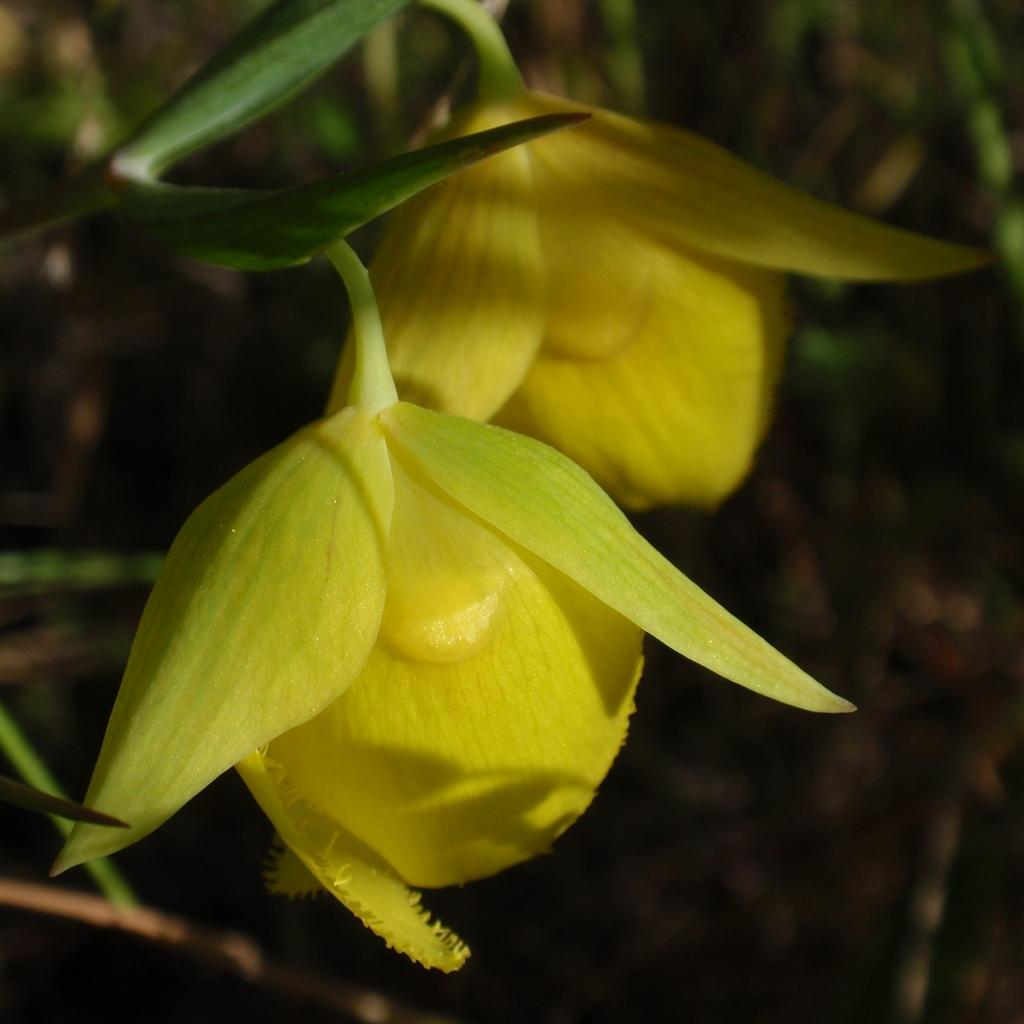What type of flowers can be seen in the image? There are yellow flowers in the image. Can you describe the background of the image? The background of the image is blurred. What type of texture can be seen on the elbow in the image? There is no elbow present in the image, as it only features yellow flowers and a blurred background. 